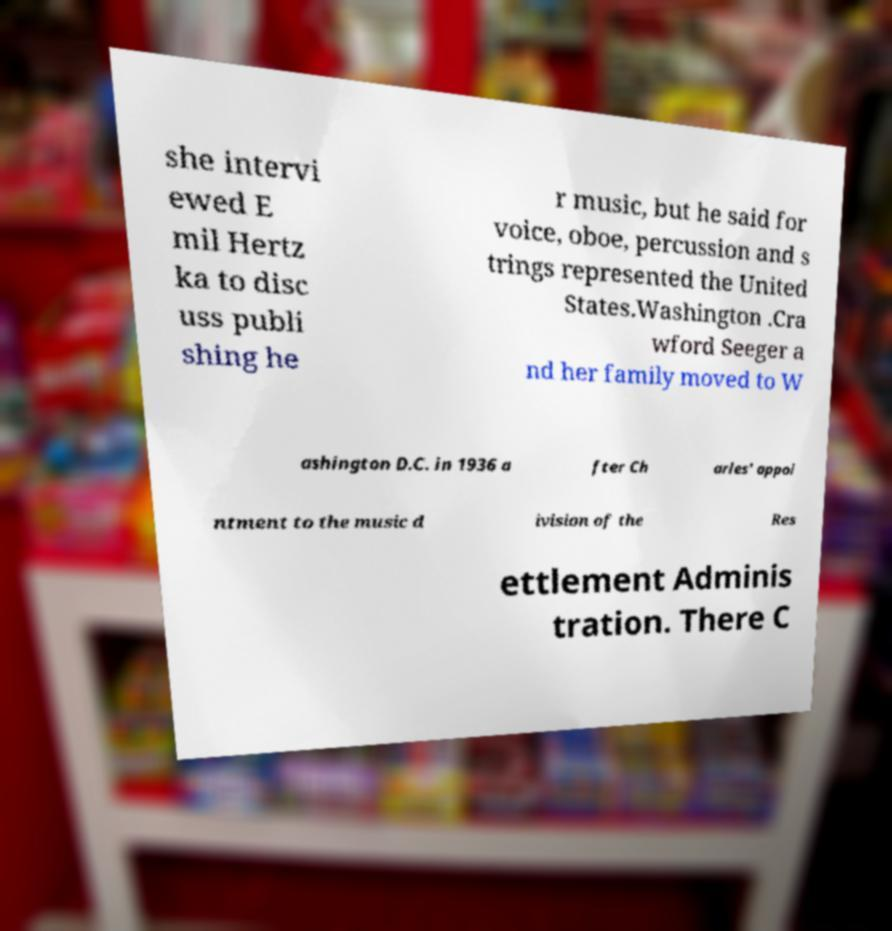Please read and relay the text visible in this image. What does it say? she intervi ewed E mil Hertz ka to disc uss publi shing he r music, but he said for voice, oboe, percussion and s trings represented the United States.Washington .Cra wford Seeger a nd her family moved to W ashington D.C. in 1936 a fter Ch arles' appoi ntment to the music d ivision of the Res ettlement Adminis tration. There C 